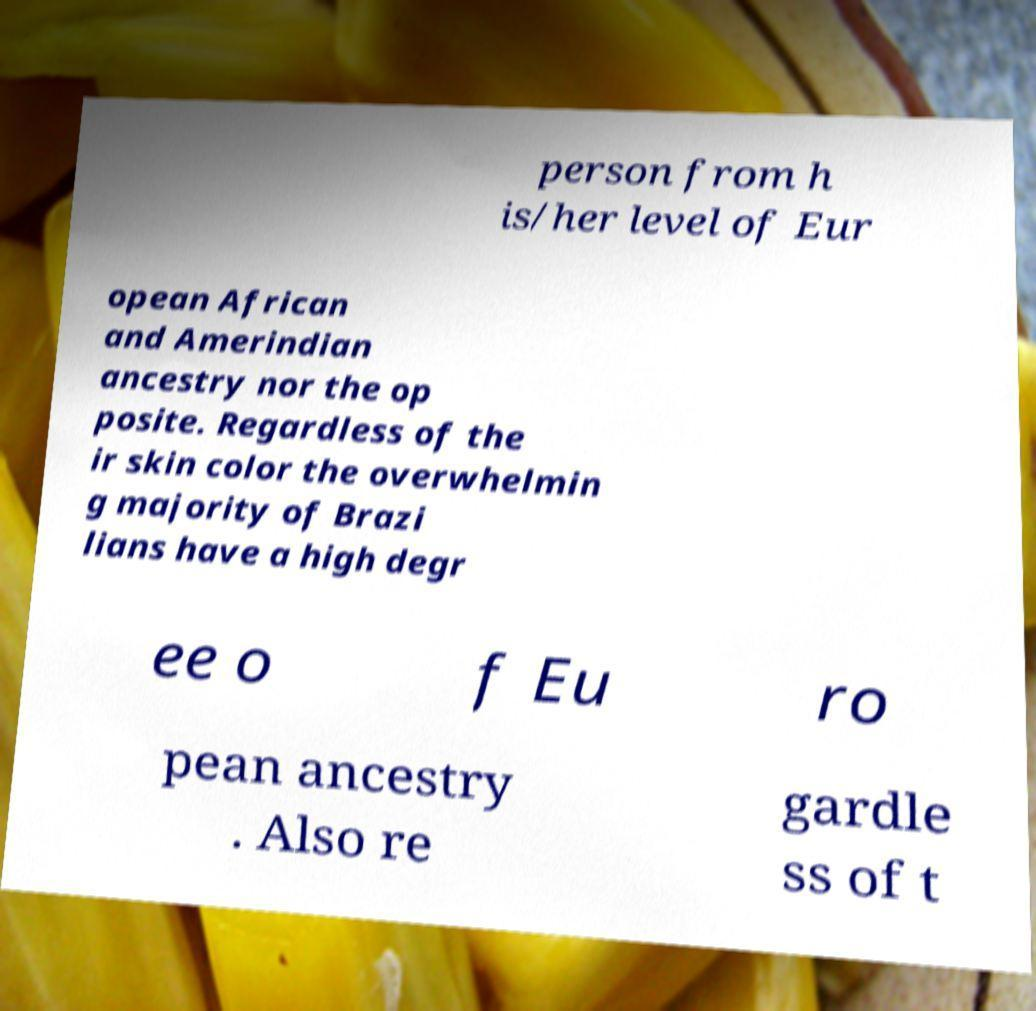Could you assist in decoding the text presented in this image and type it out clearly? person from h is/her level of Eur opean African and Amerindian ancestry nor the op posite. Regardless of the ir skin color the overwhelmin g majority of Brazi lians have a high degr ee o f Eu ro pean ancestry . Also re gardle ss of t 